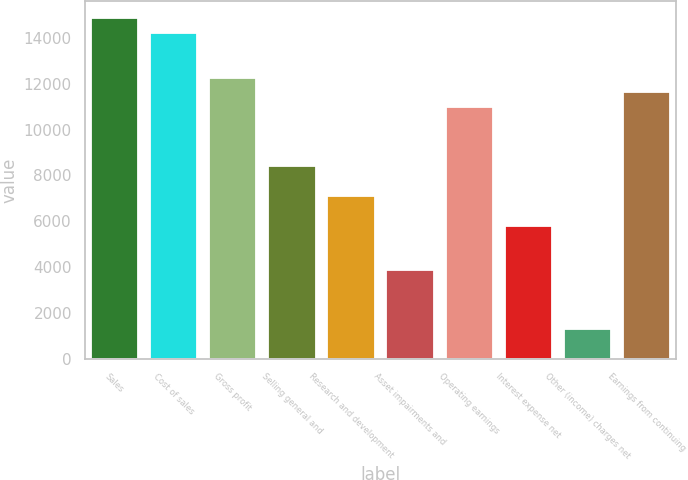<chart> <loc_0><loc_0><loc_500><loc_500><bar_chart><fcel>Sales<fcel>Cost of sales<fcel>Gross profit<fcel>Selling general and<fcel>Research and development<fcel>Asset impairments and<fcel>Operating earnings<fcel>Interest expense net<fcel>Other (income) charges net<fcel>Earnings from continuing<nl><fcel>14857.7<fcel>14211.8<fcel>12273.8<fcel>8397.94<fcel>7105.98<fcel>3876.08<fcel>10981.9<fcel>5814.02<fcel>1292.16<fcel>11627.8<nl></chart> 